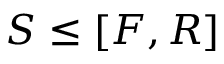Convert formula to latex. <formula><loc_0><loc_0><loc_500><loc_500>S \leq [ F , R ]</formula> 